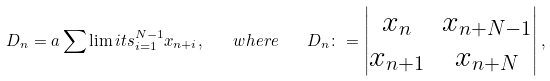Convert formula to latex. <formula><loc_0><loc_0><loc_500><loc_500>D _ { n } = a \sum \lim i t s _ { i = 1 } ^ { N - 1 } x _ { n + i } , \quad w h e r e \quad D _ { n } \colon = \left | \begin{matrix} x _ { n } & x _ { n + N - 1 } \\ x _ { n + 1 } & x _ { n + N } \end{matrix} \right | ,</formula> 